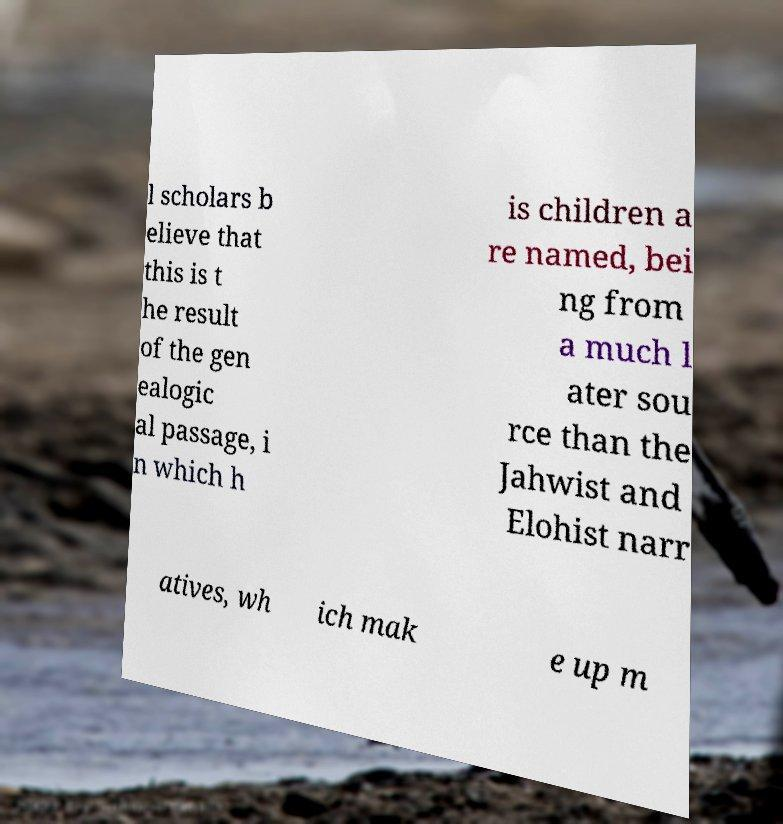There's text embedded in this image that I need extracted. Can you transcribe it verbatim? l scholars b elieve that this is t he result of the gen ealogic al passage, i n which h is children a re named, bei ng from a much l ater sou rce than the Jahwist and Elohist narr atives, wh ich mak e up m 